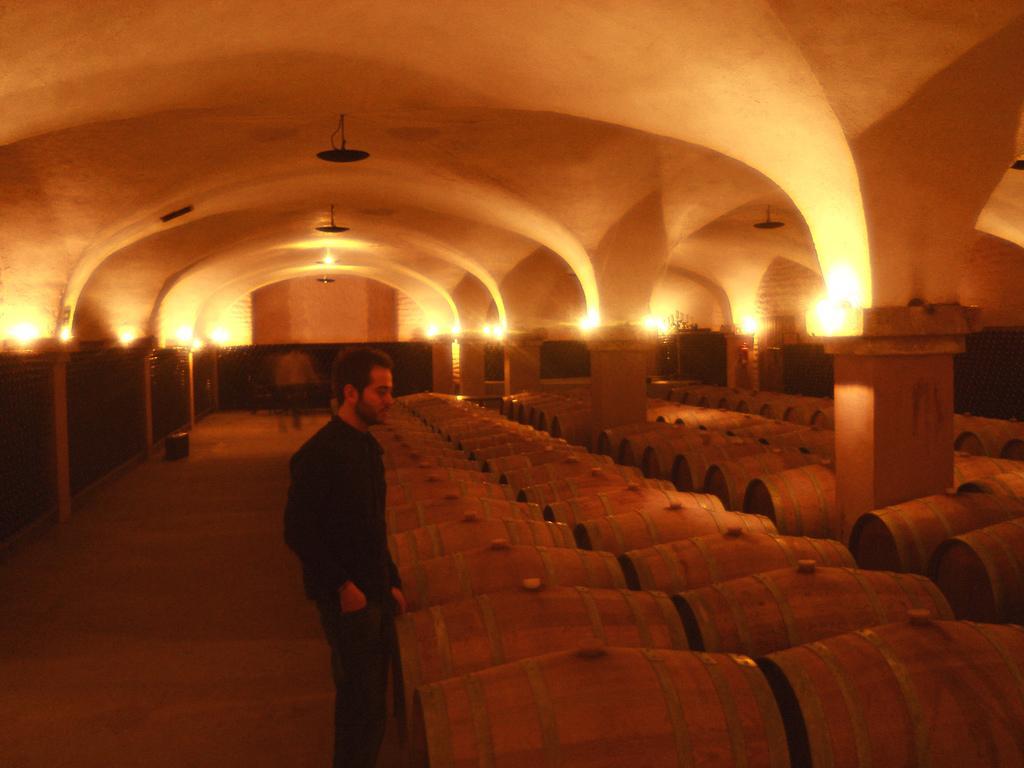Could you give a brief overview of what you see in this image? In this picture I can see a man standing, few wooden barrels and few lights to the ceiling. 